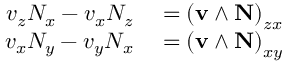Convert formula to latex. <formula><loc_0><loc_0><loc_500><loc_500>\begin{array} { r l } { v _ { z } N _ { x } - v _ { x } N _ { z } } & = \left ( v \wedge N \right ) _ { z x } } \\ { v _ { x } N _ { y } - v _ { y } N _ { x } } & = \left ( v \wedge N \right ) _ { x y } } \end{array}</formula> 